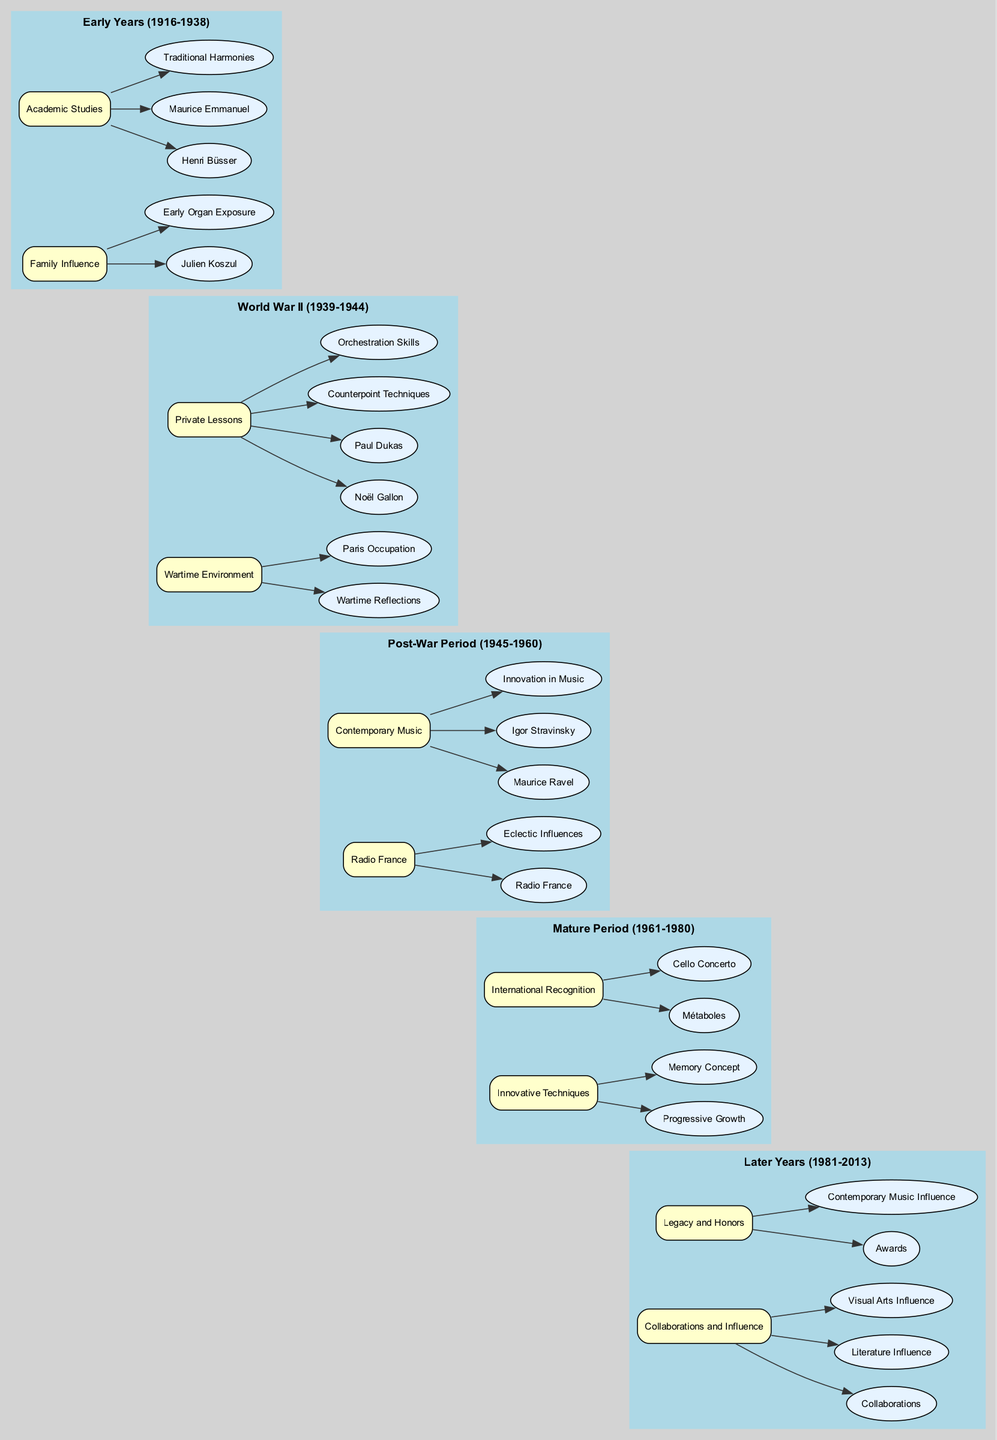What key influence is associated with Henri Dutilleux's family background? The diagram indicates that his grandfather, Julien Koszul, who was involved in music, was a key influence in his early years. This influence is tied to his early exposure to organ music.
Answer: Julien Koszul How many major periods are reflected in the diagram? By examining the distinct phases outlined in the diagram, it is clear that there are five major periods: Early Years, World War II, Post-War Period, Mature Period, and Later Years.
Answer: 5 What was one of the arts that influenced Dutilleux in his later years? The diagram shows that he was influenced by visual arts in his later years, along with literature. This suggests a broadening of his artistic influences towards various forms.
Answer: Visual Arts Influence Which influential figure did Dutilleux study composition under during his academic years? The diagram indicates that both Henri Büsser and Maurice Emmanuel were significant figures in Dutilleux's academic studies at the Paris Conservatoire. The mention of Henri Büsser specifically answers this query.
Answer: Henri Büsser What compositional technique did Dutilleux develop during his mature period? The diagram points out that during the mature period, he developed unique techniques such as 'progressive growth' and 'memory concept', where 'progressive growth' is a standout technique elaborated upon in that time frame.
Answer: Progressive Growth How did the wartime environment impact Dutilleux's music? The diagram states that his compositional output during World War II was deeply influenced by introspective and reflective themes arising from the events and atmosphere of the war. Thus, the impact is primarily characterized as reflective themes.
Answer: Reflective Themes What landmark works contributed to Dutilleux’s international recognition? The diagram specifically highlights 'Métaboles' and 'Cello Concerto' as key works that earned him international recognition, indicating their significance in his career trajectory.
Answer: Métaboles What was Dutilleux's primary focus during World War II, according to the diagram? The diagram clearly shows that his primary focus during the World War II period was introspective work, which suggests a contemplative approach in his compositions during that time.
Answer: Introspective Themes What connection does Dutilleux's work at Radio France have with his evolving style? The diagram explicitly connects his time working at Radio France with exposure to diverse music styles, which contributed to his evolving compositional style. Therefore, this workplace experience was crucial for his artistic development.
Answer: Eclectic Influences 